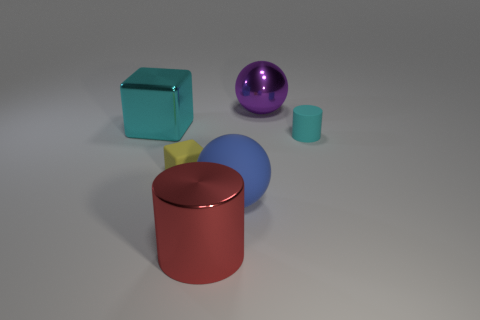What is the color of the large metal cylinder? red 